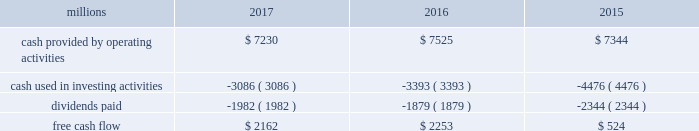Adjusted net income of $ 4.6 billion translated into adjusted earnings of $ 5.79 per diluted share , a best- ever performance .
F0b7 freight revenues 2013 our freight revenues increased 7% ( 7 % ) year-over-year to $ 19.8 billion driven by volume growth of 2% ( 2 % ) , higher fuel surcharge revenue , and core pricing gains .
Growth in frac sand , coal , and intermodal shipments more than offset declines in grain , crude oil , finished vehicles , and rock shipments .
F0b7 fuel prices 2013 our average price of diesel fuel in 2017 was $ 1.81 per gallon , an increase of 22% ( 22 % ) from 2016 , as both crude oil and conversion spreads between crude oil and diesel increased in 2017 .
The higher price resulted in increased operating expenses of $ 334 million ( excluding any impact from year- over-year volume growth ) .
Gross-ton miles increased 5% ( 5 % ) , which also drove higher fuel expense .
Our fuel consumption rate , computed as gallons of fuel consumed divided by gross ton-miles in thousands , improved 2% ( 2 % ) .
F0b7 free cash flow 2013 cash generated by operating activities totaled $ 7.2 billion , yielding free cash flow of $ 2.2 billion after reductions of $ 3.1 billion for cash used in investing activities and $ 2 billion in dividends , which included a 10% ( 10 % ) increase in our quarterly dividend per share from $ 0.605 to $ 0.665 declared and paid in the fourth quarter of 2017 .
Free cash flow is defined as cash provided by operating activities less cash used in investing activities and dividends paid .
Free cash flow is not considered a financial measure under gaap by sec regulation g and item 10 of sec regulation s-k and may not be defined and calculated by other companies in the same manner .
We believe free cash flow is important to management and investors in evaluating our financial performance and measures our ability to generate cash without additional external financings .
Free cash flow should be considered in addition to , rather than as a substitute for , cash provided by operating activities .
The table reconciles cash provided by operating activities ( gaap measure ) to free cash flow ( non-gaap measure ) : .
2018 outlook f0b7 safety 2013 operating a safe railroad benefits all our constituents : our employees , customers , shareholders and the communities we serve .
We will continue using a multi-faceted approach to safety , utilizing technology , risk assessment , training and employee engagement , quality control , and targeted capital investments .
We will continue using and expanding the deployment of total safety culture and courage to care throughout our operations , which allows us to identify and implement best practices for employee and operational safety .
We will continue our efforts to increase detection of rail defects ; improve or close crossings ; and educate the public and law enforcement agencies about crossing safety through a combination of our own programs ( including risk assessment strategies ) , industry programs and local community activities across our network .
F0b7 network operations 2013 in 2018 , we will continue to align resources with customer demand , maintain an efficient network , and ensure surge capability of our assets .
F0b7 fuel prices 2013 fuel price projections for crude oil and natural gas continue to fluctuate in the current environment .
We again could see volatile fuel prices during the year , as they are sensitive to global and u.s .
Domestic demand , refining capacity , geopolitical events , weather conditions and other factors .
As prices fluctuate , there will be a timing impact on earnings , as our fuel surcharge programs trail increases or decreases in fuel price by approximately two months .
Lower fuel prices could have a positive impact on the economy by increasing consumer discretionary spending that potentially could increase demand for various consumer products that we transport .
Alternatively , lower fuel prices could likely have a negative impact on other commodities such as coal and domestic drilling-related shipments. .
In 2017 what was the ratio of the cash provided by operating activities to the free cash flow? 
Computations: (2162 / 7230)
Answer: 0.29903. 